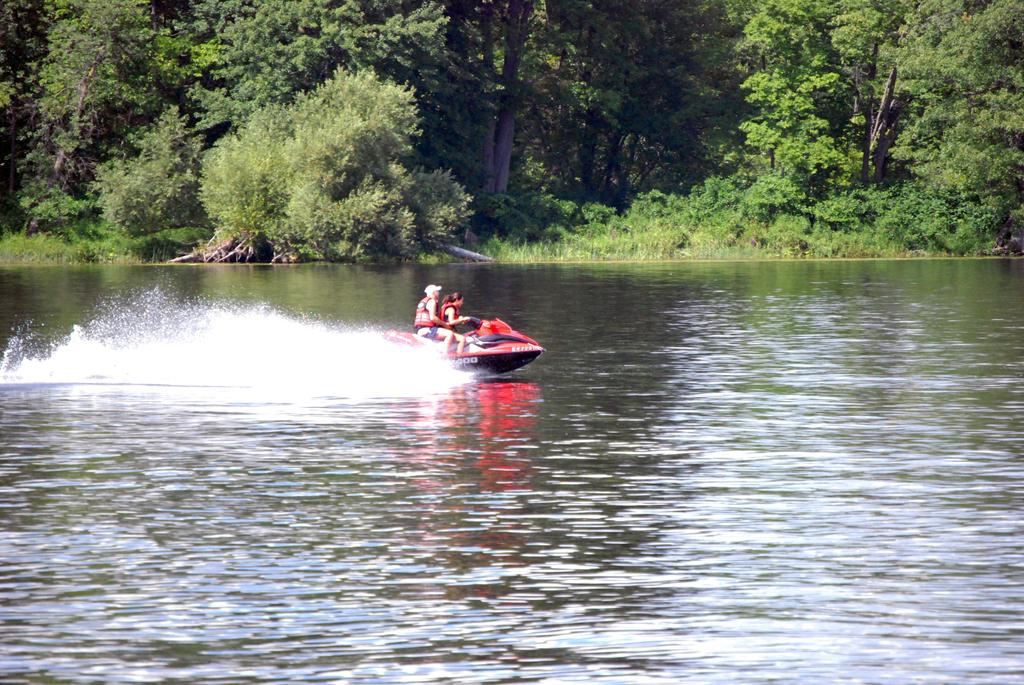How many people are in the image? There are two persons in the image. What are the persons wearing? The persons are wearing life jackets. What are the persons sitting on? The persons are sitting on a water bike. What is the water bike doing? The water bike is floating on the water. What can be seen in the background of the image? There are trees visible in the background of the image. What type of salt can be seen on the water bike? There is no salt present on the water bike in the image. Is there a party happening in the image? There is no indication of a party in the image; it shows two people sitting on a water bike. 